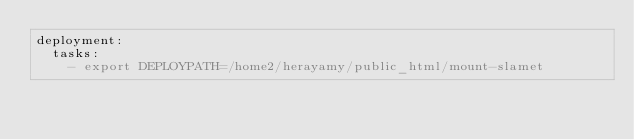Convert code to text. <code><loc_0><loc_0><loc_500><loc_500><_YAML_>deployment:
  tasks:
    - export DEPLOYPATH=/home2/herayamy/public_html/mount-slamet
</code> 